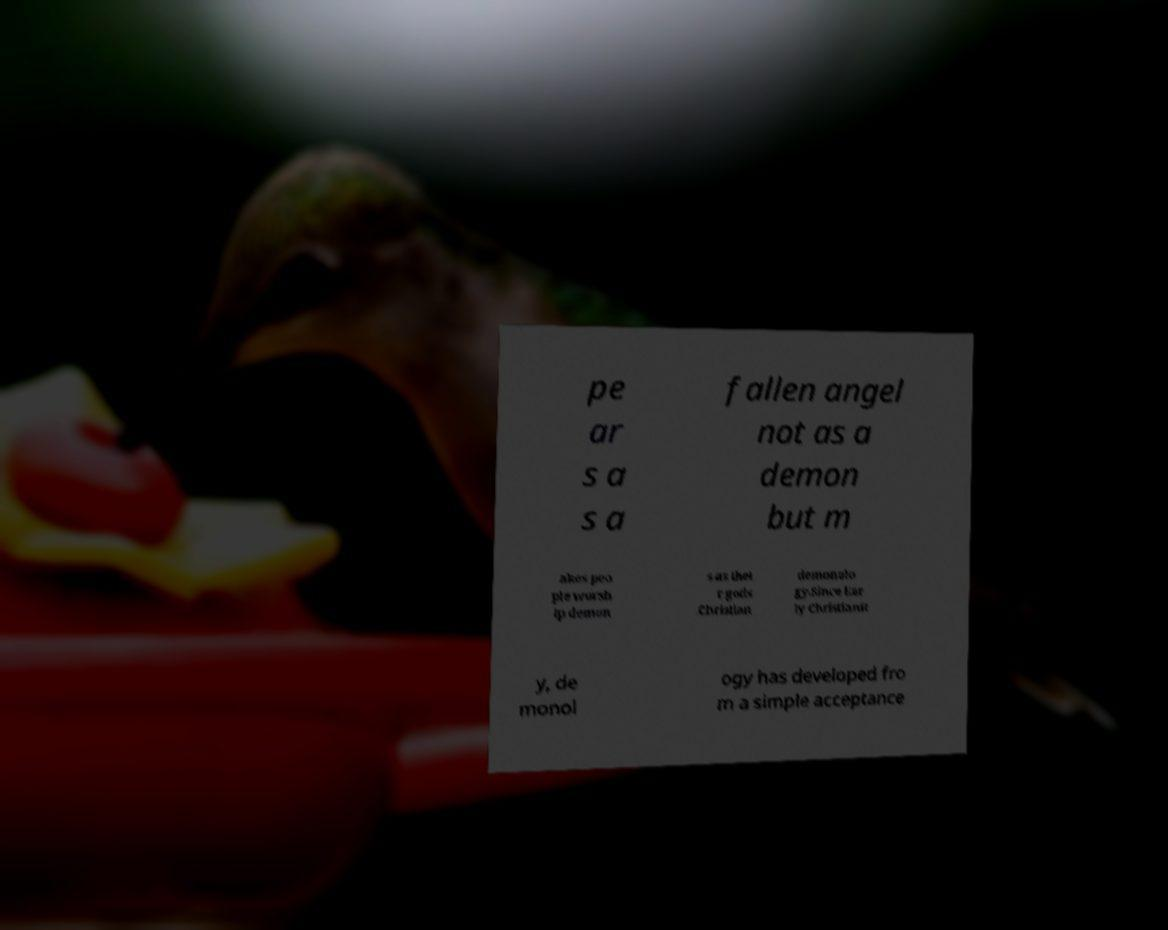Can you accurately transcribe the text from the provided image for me? pe ar s a s a fallen angel not as a demon but m akes peo ple worsh ip demon s as thei r gods .Christian demonolo gy.Since Ear ly Christianit y, de monol ogy has developed fro m a simple acceptance 